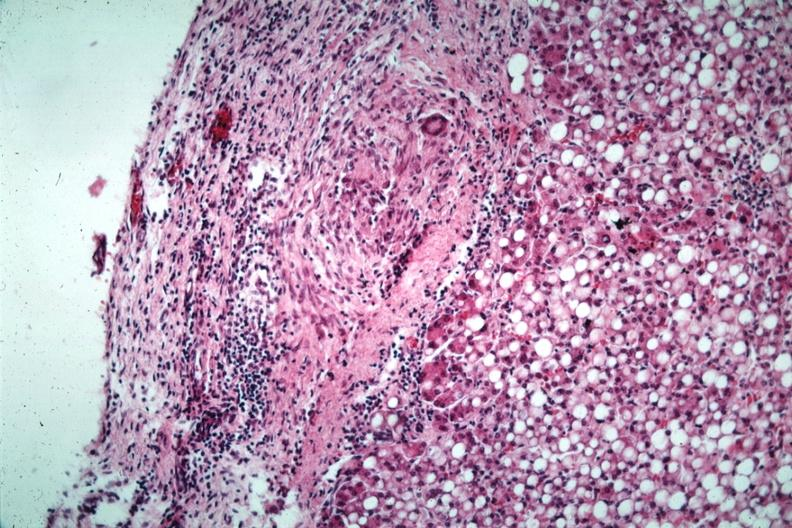s opened abdominal cavity with massive tumor in omentum none apparent in liver nor over peritoneal surfaces gut present?
Answer the question using a single word or phrase. No 